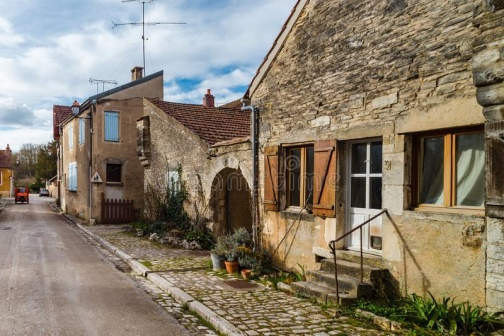What kind of stories could this village tell from its past? This village, with its quaint stone houses and narrow, cobblestone streets, likely has a rich tapestry of stories woven through its history. Tales of local farmers and artisans, who lived simple yet rewarding lives, could be a common thread. Stories of the village gathering in the old stone square to celebrate harvest festivals, filled with music, dance, and feasting, would evoke a sense of community spirit. Perhaps legends of a mysterious traveler who once stayed in the village, leaving behind strange artifacts and tales of distant lands, would add an element of intrigue and curiosity to the village's lore.  What kind of daily activities might you see in this village during the day and evening? During the day, you might see villagers tending to their gardens, chatting with neighbors by the gates, or walking down the street with baskets filled with local produce. Children could be playing games on the cobblestones, their laughter echoing through the village. In the evening, the smell of delicious home-cooked meals may fill the air as families gather for dinner. The street lamp would light up, casting a warm glow as villagers finish up their day, taking a leisurely evening stroll, or enjoying a quiet moment of reflection on their front steps. The village would be alive with a quiet, enduring rhythm that speaks to the heart of simple, communal living. 